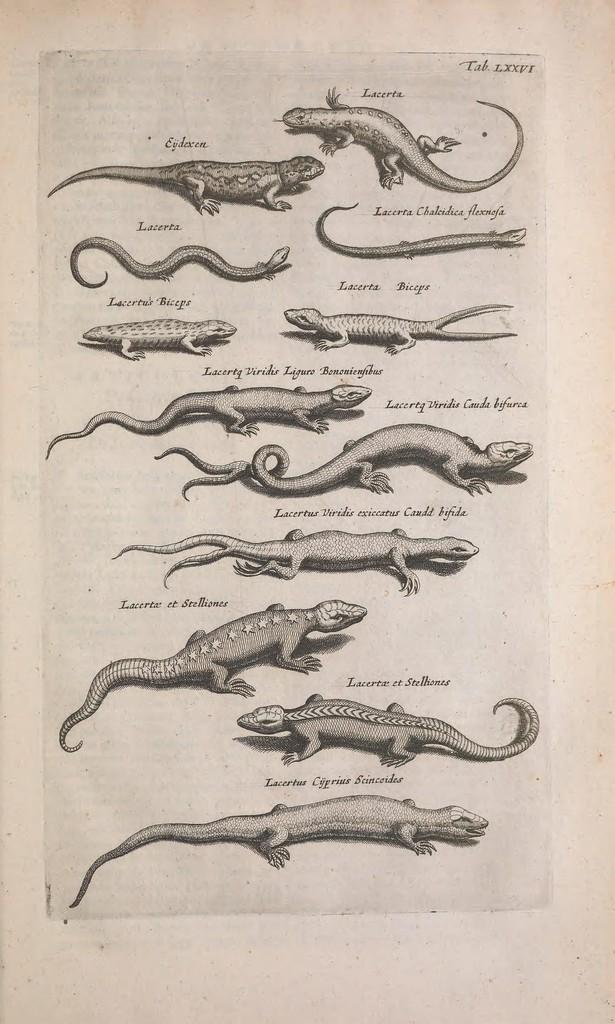Can you describe this image briefly? This is a paper. On that there are images of different animals with names. 